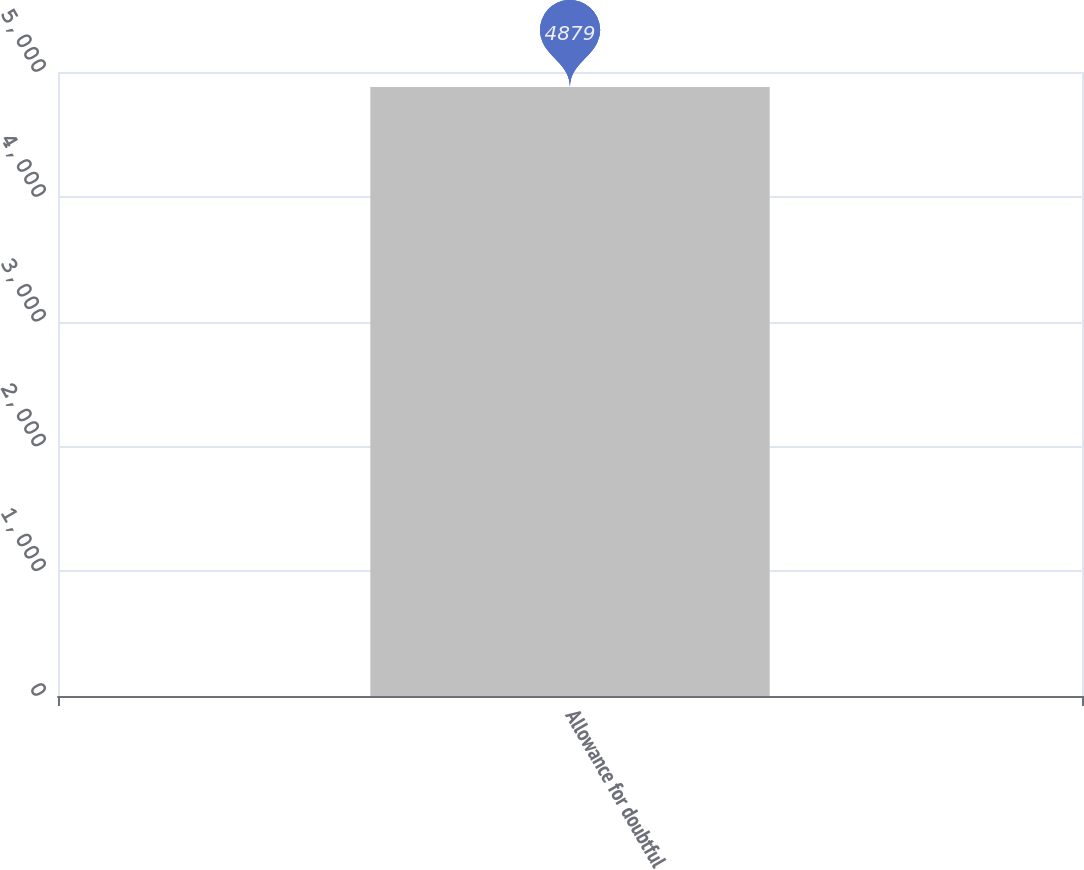Convert chart to OTSL. <chart><loc_0><loc_0><loc_500><loc_500><bar_chart><fcel>Allowance for doubtful<nl><fcel>4879<nl></chart> 